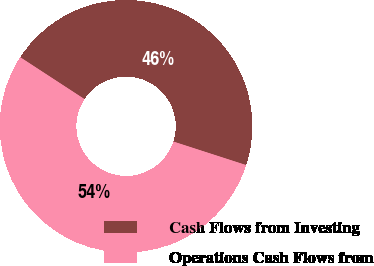Convert chart. <chart><loc_0><loc_0><loc_500><loc_500><pie_chart><fcel>Cash Flows from Investing<fcel>Operations Cash Flows from<nl><fcel>45.78%<fcel>54.22%<nl></chart> 